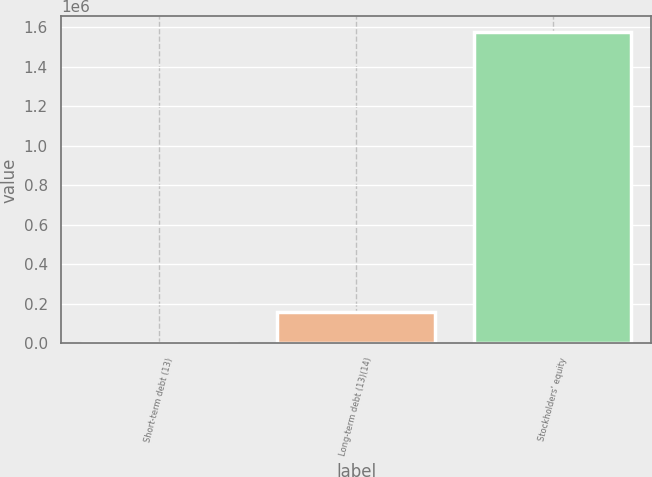<chart> <loc_0><loc_0><loc_500><loc_500><bar_chart><fcel>Short-term debt (13)<fcel>Long-term debt (13)(14)<fcel>Stockholders' equity<nl><fcel>1153<fcel>158811<fcel>1.57773e+06<nl></chart> 